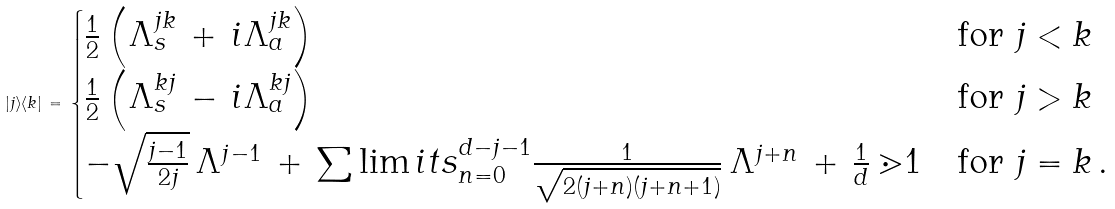<formula> <loc_0><loc_0><loc_500><loc_500>| j \rangle \langle k | \, = \, \begin{cases} \frac { 1 } { 2 } \left ( \Lambda ^ { j k } _ { s } \, + \, i \Lambda ^ { j k } _ { a } \right ) & \text {for } j < k \\ \frac { 1 } { 2 } \left ( \Lambda ^ { k j } _ { s } \, - \, i \Lambda ^ { k j } _ { a } \right ) & \text {for } j > k \\ - \sqrt { \frac { j - 1 } { 2 j } } \, \Lambda ^ { j - 1 } \, + \, \sum \lim i t s _ { n = 0 } ^ { d - j - 1 } \frac { 1 } { \sqrt { 2 ( j + n ) ( j + n + 1 ) } } \, \Lambda ^ { j + n } \, + \, \frac { 1 } { d } \, \mathbb { m } { 1 } & \text {for } j = k \, . \end{cases}</formula> 